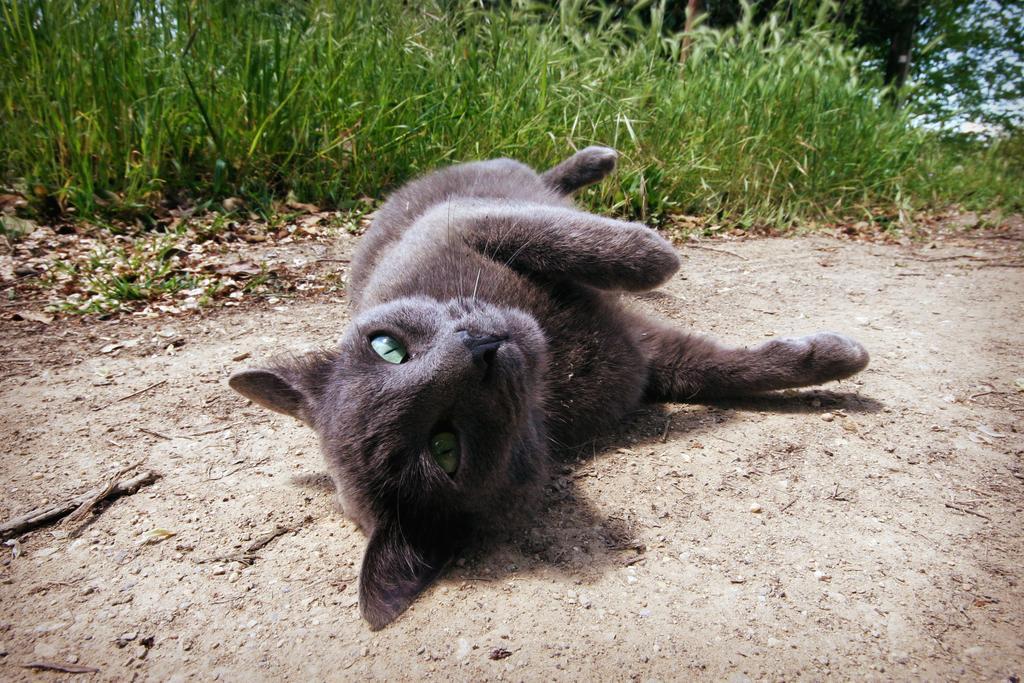Describe this image in one or two sentences. In this image we can see a cat on the ground, there are plants, trees, also we can see the sky. 